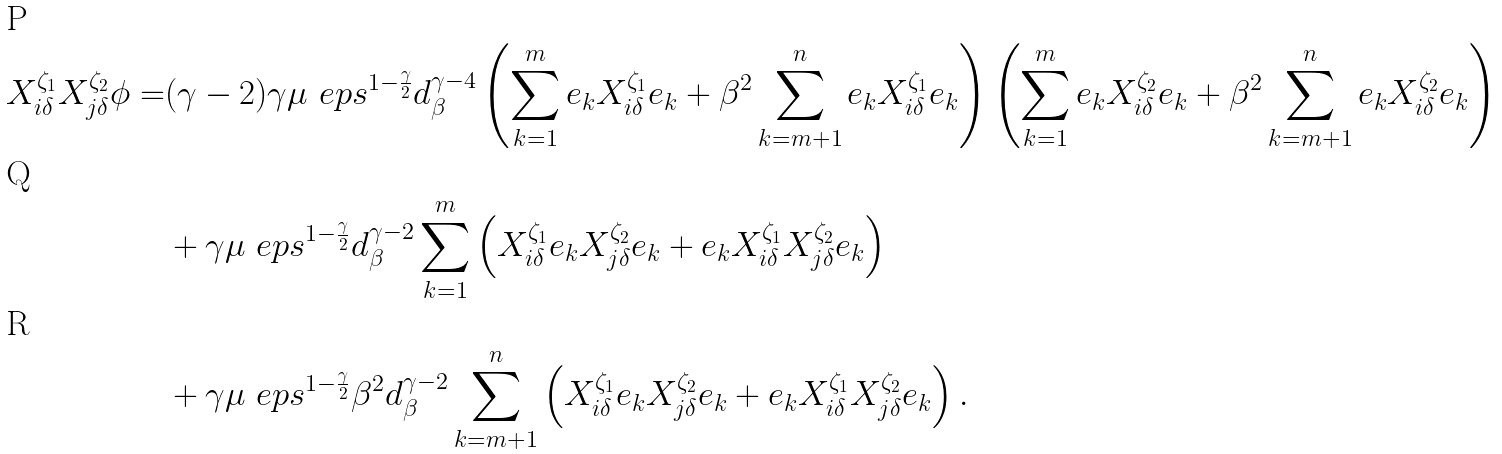<formula> <loc_0><loc_0><loc_500><loc_500>X ^ { \zeta _ { 1 } } _ { i \delta } X ^ { \zeta _ { 2 } } _ { j \delta } \phi = & ( \gamma - 2 ) \gamma \mu \ e p s ^ { 1 - \frac { \gamma } { 2 } } d _ { \beta } ^ { \gamma - 4 } \left ( \sum _ { k = 1 } ^ { m } e _ { k } X _ { i \delta } ^ { \zeta _ { 1 } } e _ { k } + \beta ^ { 2 } \sum _ { k = m + 1 } ^ { n } e _ { k } X _ { i \delta } ^ { \zeta _ { 1 } } e _ { k } \right ) \left ( \sum _ { k = 1 } ^ { m } e _ { k } X _ { i \delta } ^ { \zeta _ { 2 } } e _ { k } + \beta ^ { 2 } \sum _ { k = m + 1 } ^ { n } e _ { k } X _ { i \delta } ^ { \zeta _ { 2 } } e _ { k } \right ) \\ & + \gamma \mu \ e p s ^ { 1 - \frac { \gamma } { 2 } } d _ { \beta } ^ { \gamma - 2 } \sum _ { k = 1 } ^ { m } \left ( X _ { i \delta } ^ { \zeta _ { 1 } } e _ { k } X _ { j \delta } ^ { \zeta _ { 2 } } e _ { k } + e _ { k } X _ { i \delta } ^ { \zeta _ { 1 } } X _ { j \delta } ^ { \zeta _ { 2 } } e _ { k } \right ) \\ & + \gamma \mu \ e p s ^ { 1 - \frac { \gamma } { 2 } } \beta ^ { 2 } d _ { \beta } ^ { \gamma - 2 } \sum _ { k = m + 1 } ^ { n } \left ( X _ { i \delta } ^ { \zeta _ { 1 } } e _ { k } X _ { j \delta } ^ { \zeta _ { 2 } } e _ { k } + e _ { k } X _ { i \delta } ^ { \zeta _ { 1 } } X _ { j \delta } ^ { \zeta _ { 2 } } e _ { k } \right ) .</formula> 